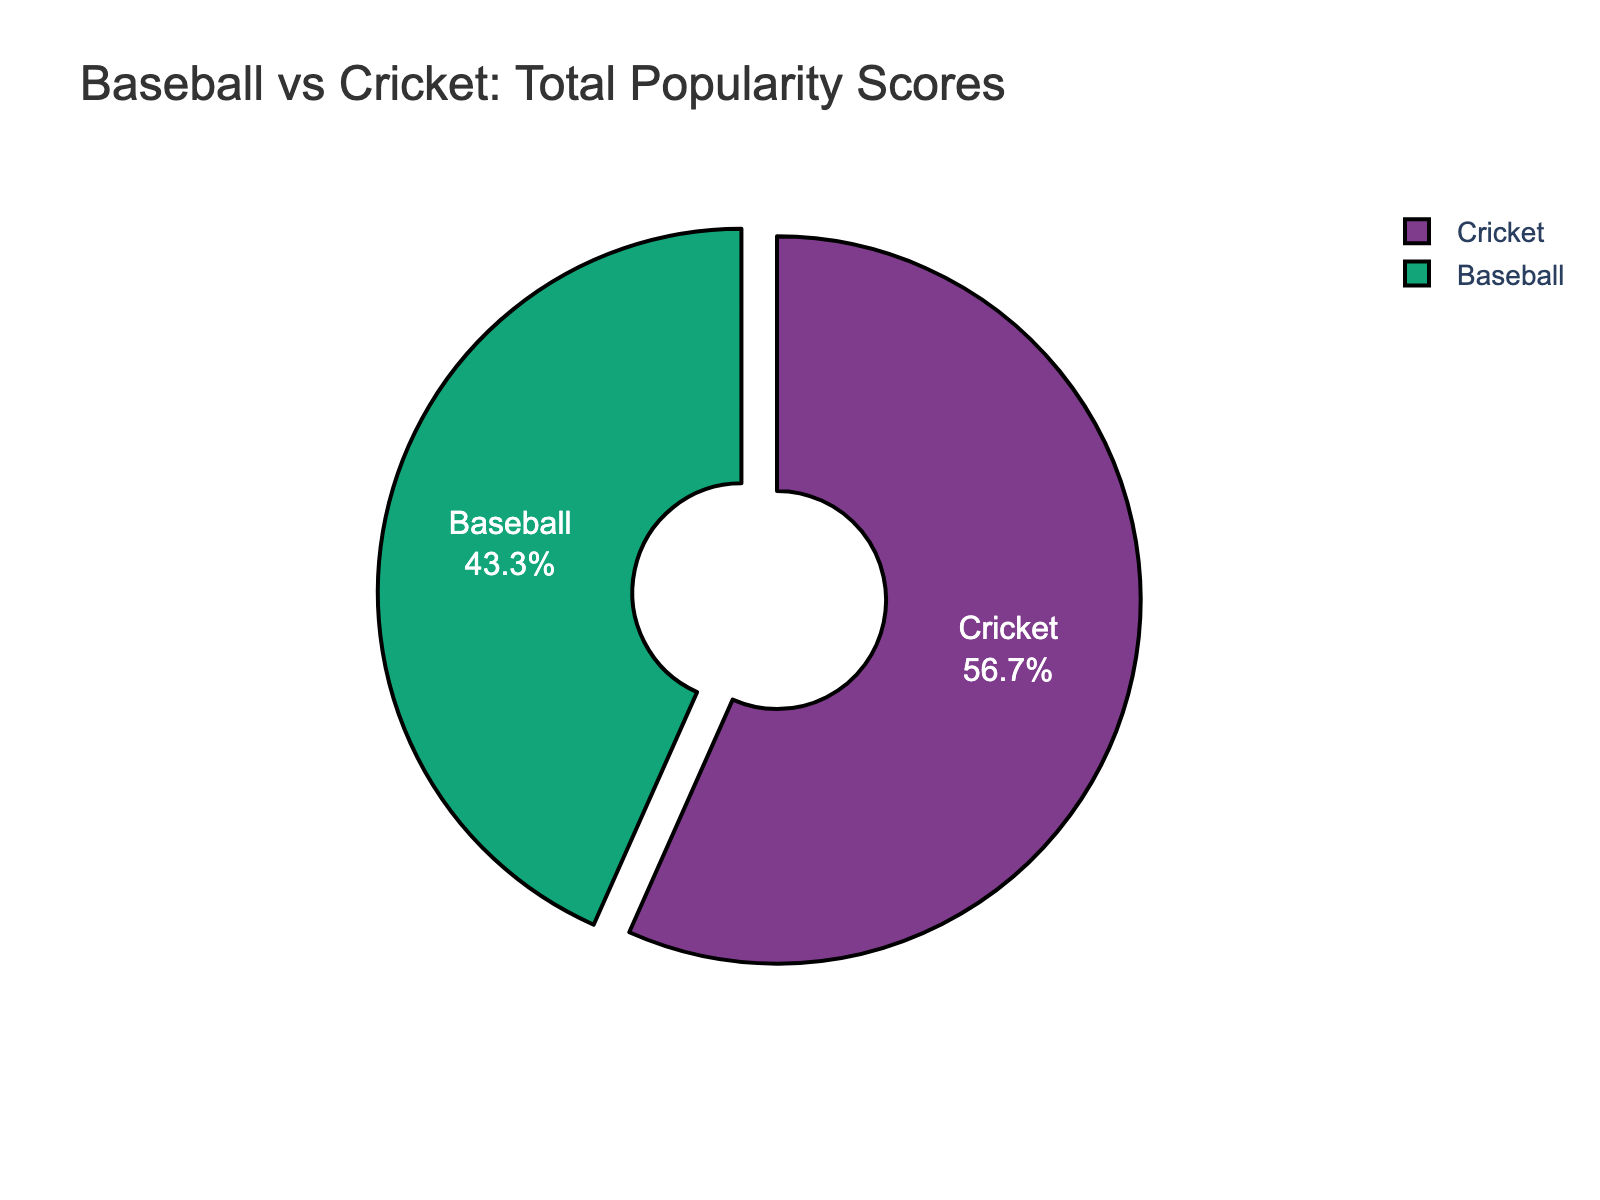what percentage of the total popularity score does baseball represent? Baseball's percentage can be calculated by dividing baseball's total popularity score by the combined total of baseball and cricket scores, then multiplying by 100. The combined total is 243 (baseball) + 335 (cricket) = 578. So, (243 / 578) * 100 ≈ 42%
Answer: 42% which sport has a higher total popularity score? By looking at the pie chart, cricket has the larger section, indicating a higher total popularity score compared to baseball.
Answer: Cricket how much more popular is cricket compared to baseball, in terms of popularity score? Subtract baseball's total popularity score from cricket's. Cricket (335) - Baseball (243) = 92
Answer: 92 what is the combined popularity score for both sports? Add the total popularity scores for baseball and cricket. 243 (baseball) + 335 (cricket) = 578
Answer: 578 if baseball's popularity score doubled, what would its new percentage of the total be? First double baseball's score: 243 * 2 = 486. The new total is 486 (baseball) + 335 (cricket) = 821. The new percentage is (486 / 821) * 100 ≈ 59%
Answer: 59% what fraction of the total popularity score is made up by cricket? Cricket's fraction of the total is cricket's score divided by the combined total. So, 335 / 578 = 335/578
Answer: 335/578 how much larger is cricket's share of the total popularity score compared to baseball's? Cricket's share minus baseball's share. Cricket = 335, Baseball = 243. So, the difference is 335 - 243 = 92. In percentage terms: ((92 / 578) * 100) ≈ 16%
Answer: 16% which sport would dominate the pie chart if the popularity scores from the United States and India were removed? After removing the scores from the United States (65 for baseball) and India (70 for cricket): Baseball = 243 - 65 = 178, Cricket = 335 - 70 = 265. Cricket would still have the higher score: 265 > 178
Answer: Cricket what percentage of the popularity score for each sport is contributed by its best-performing market? For baseball, the US: (65 / 243) * 100 ≈ 27%. For cricket, India: (70 / 335) * 100 ≈ 21%
Answer: Baseball: 27%, Cricket: 21% if both sports lost 10 popularity points from each market, which sport would then have the higher total popularity score? Subtract 10 per market from each sport. Baseball: 243 - (10 * 8) = 243 - 80 = 163. Cricket: 335 - (10 * 8) = 335 - 80 = 255. Cricket would still have the higher score: 255 > 163
Answer: Cricket 